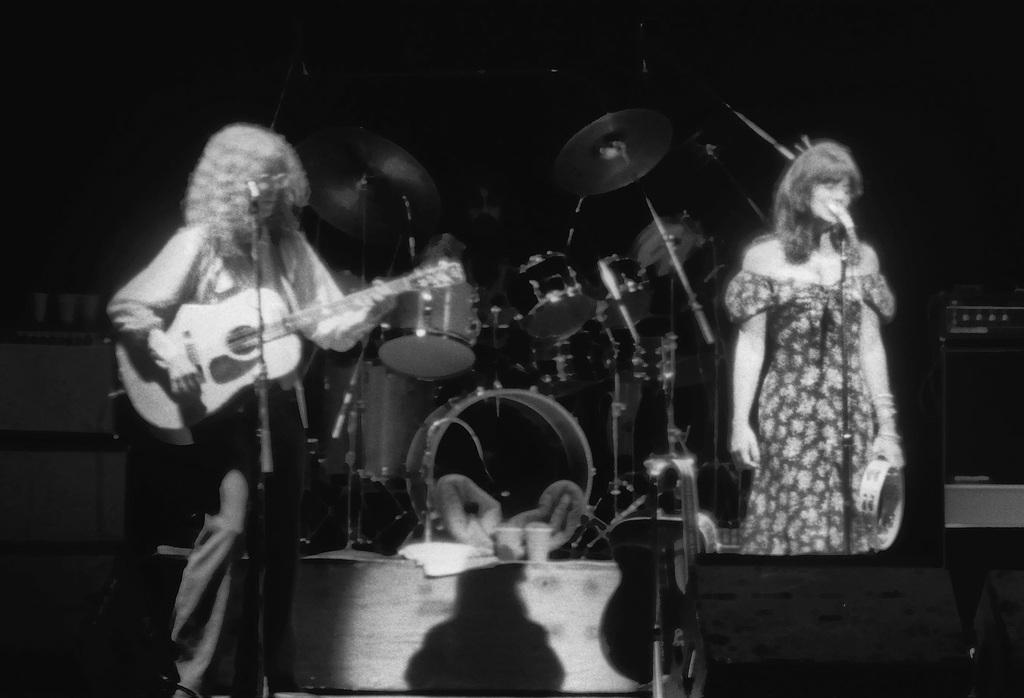In one or two sentences, can you explain what this image depicts? In this image I can see few people are standing and also one of them is holding a guitar. I can also see few mics and a drum set in the background. 